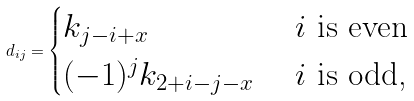Convert formula to latex. <formula><loc_0><loc_0><loc_500><loc_500>d _ { i j } = \begin{cases} k _ { j - i + x } & \text { $i$ is even} \\ ( - 1 ) ^ { j } k _ { 2 + i - j - x } & \text { $i$ is odd,} \end{cases}</formula> 